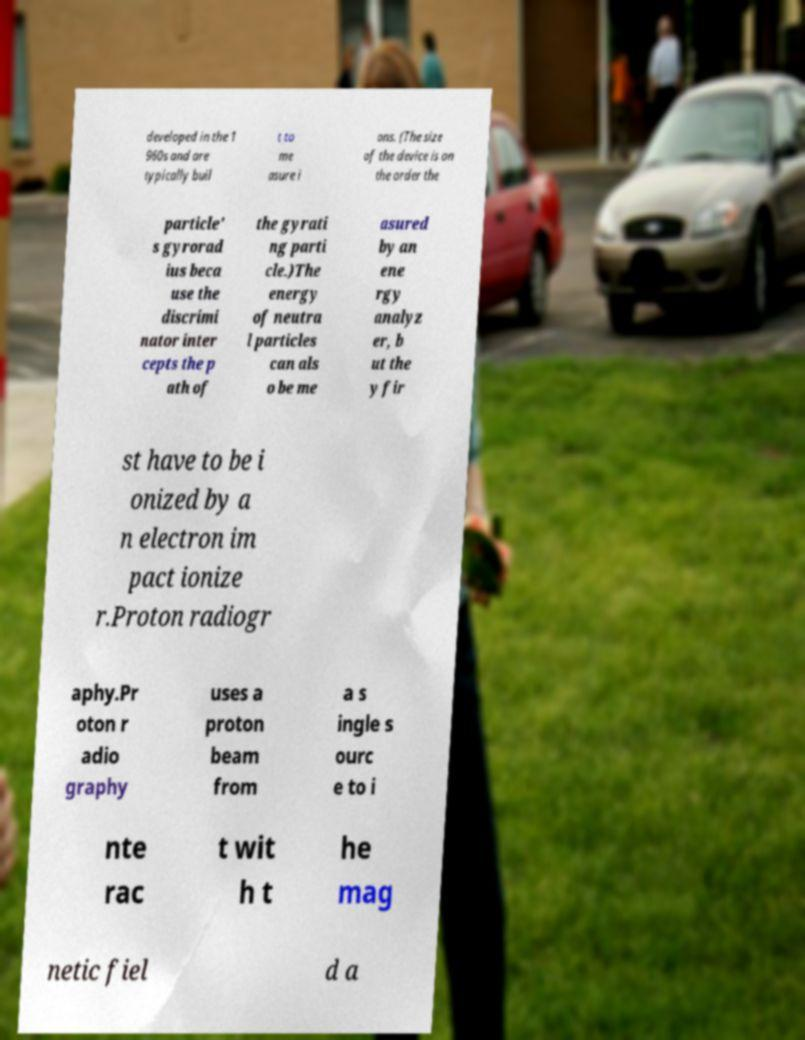I need the written content from this picture converted into text. Can you do that? developed in the 1 960s and are typically buil t to me asure i ons. (The size of the device is on the order the particle' s gyrorad ius beca use the discrimi nator inter cepts the p ath of the gyrati ng parti cle.)The energy of neutra l particles can als o be me asured by an ene rgy analyz er, b ut the y fir st have to be i onized by a n electron im pact ionize r.Proton radiogr aphy.Pr oton r adio graphy uses a proton beam from a s ingle s ourc e to i nte rac t wit h t he mag netic fiel d a 